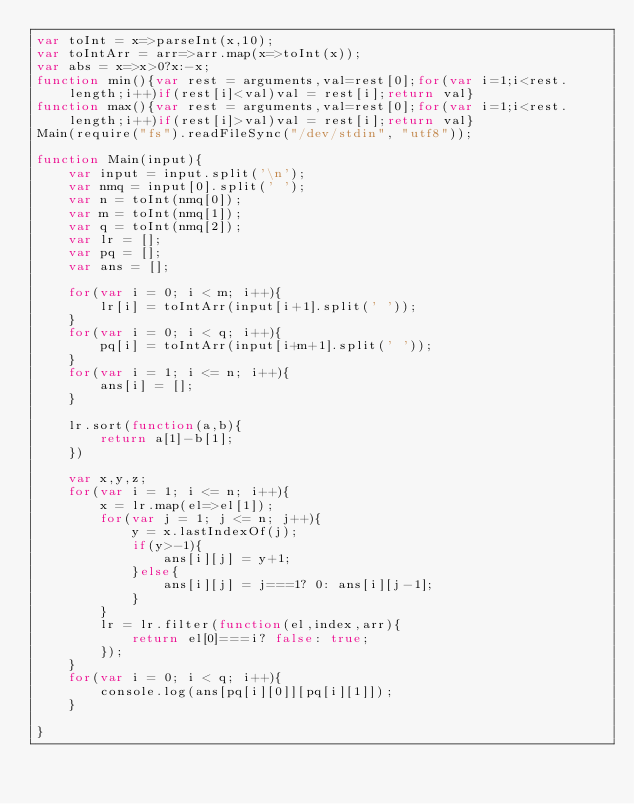<code> <loc_0><loc_0><loc_500><loc_500><_JavaScript_>var toInt = x=>parseInt(x,10);
var toIntArr = arr=>arr.map(x=>toInt(x));
var abs = x=>x>0?x:-x;
function min(){var rest = arguments,val=rest[0];for(var i=1;i<rest.length;i++)if(rest[i]<val)val = rest[i];return val}
function max(){var rest = arguments,val=rest[0];for(var i=1;i<rest.length;i++)if(rest[i]>val)val = rest[i];return val}
Main(require("fs").readFileSync("/dev/stdin", "utf8"));
 
function Main(input){
	var input = input.split('\n');
	var nmq = input[0].split(' ');
	var n = toInt(nmq[0]);
	var m = toInt(nmq[1]);
	var q = toInt(nmq[2]);
	var lr = [];
	var pq = [];
	var ans = [];

	for(var i = 0; i < m; i++){
		lr[i] = toIntArr(input[i+1].split(' '));
	}
	for(var i = 0; i < q; i++){
		pq[i] = toIntArr(input[i+m+1].split(' '));
	}
	for(var i = 1; i <= n; i++){
		ans[i] = [];
	}

	lr.sort(function(a,b){
		return a[1]-b[1];
	})

	var x,y,z;
	for(var i = 1; i <= n; i++){
		x = lr.map(el=>el[1]);
		for(var j = 1; j <= n; j++){
			y = x.lastIndexOf(j);
			if(y>-1){
				ans[i][j] = y+1;
			}else{
				ans[i][j] = j===1? 0: ans[i][j-1];
			}
		}
		lr = lr.filter(function(el,index,arr){
			return el[0]===i? false: true;
		});
	}
	for(var i = 0; i < q; i++){
		console.log(ans[pq[i][0]][pq[i][1]]);
	}

}</code> 